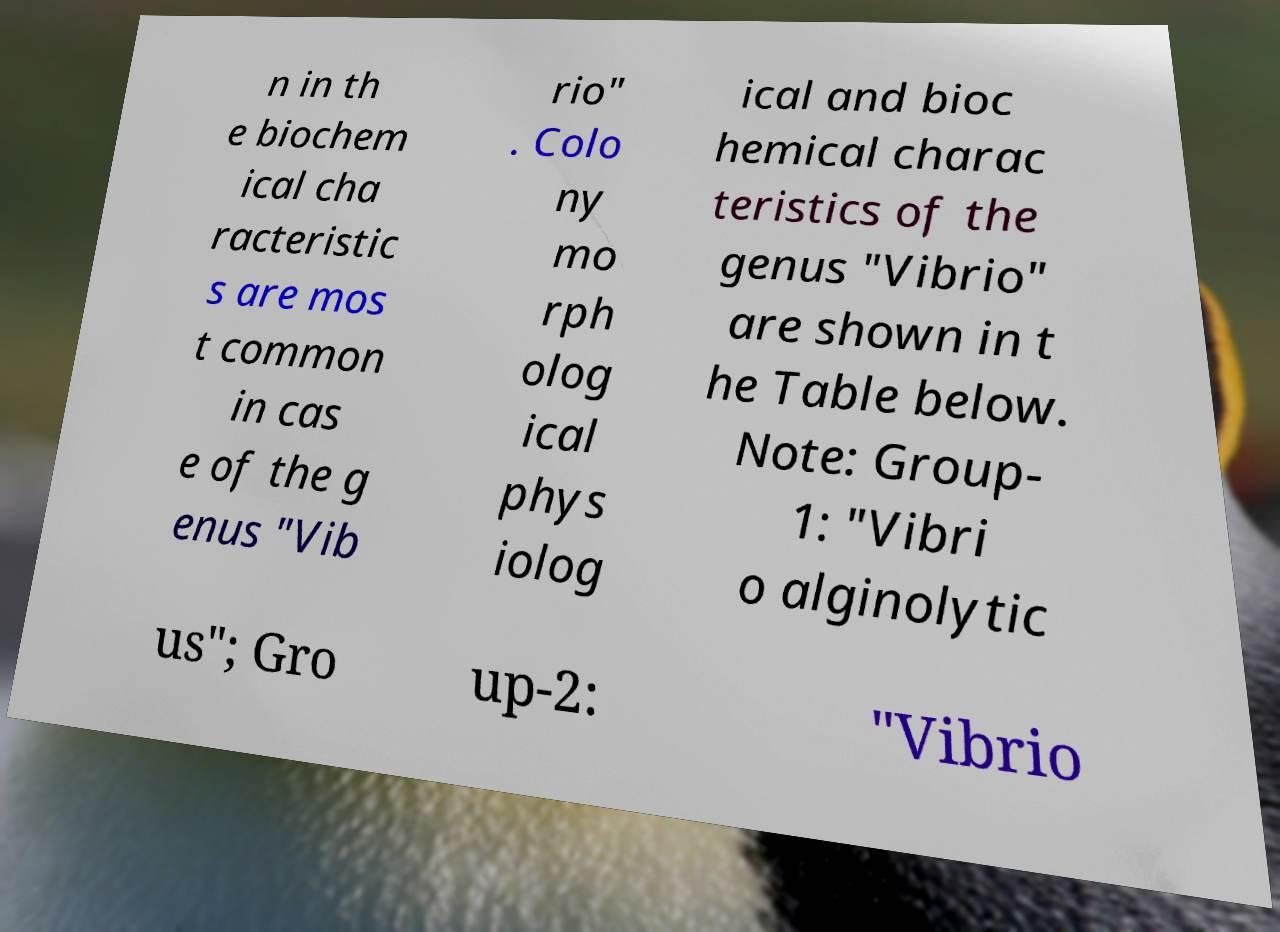There's text embedded in this image that I need extracted. Can you transcribe it verbatim? n in th e biochem ical cha racteristic s are mos t common in cas e of the g enus "Vib rio" . Colo ny mo rph olog ical phys iolog ical and bioc hemical charac teristics of the genus "Vibrio" are shown in t he Table below. Note: Group- 1: "Vibri o alginolytic us"; Gro up-2: "Vibrio 